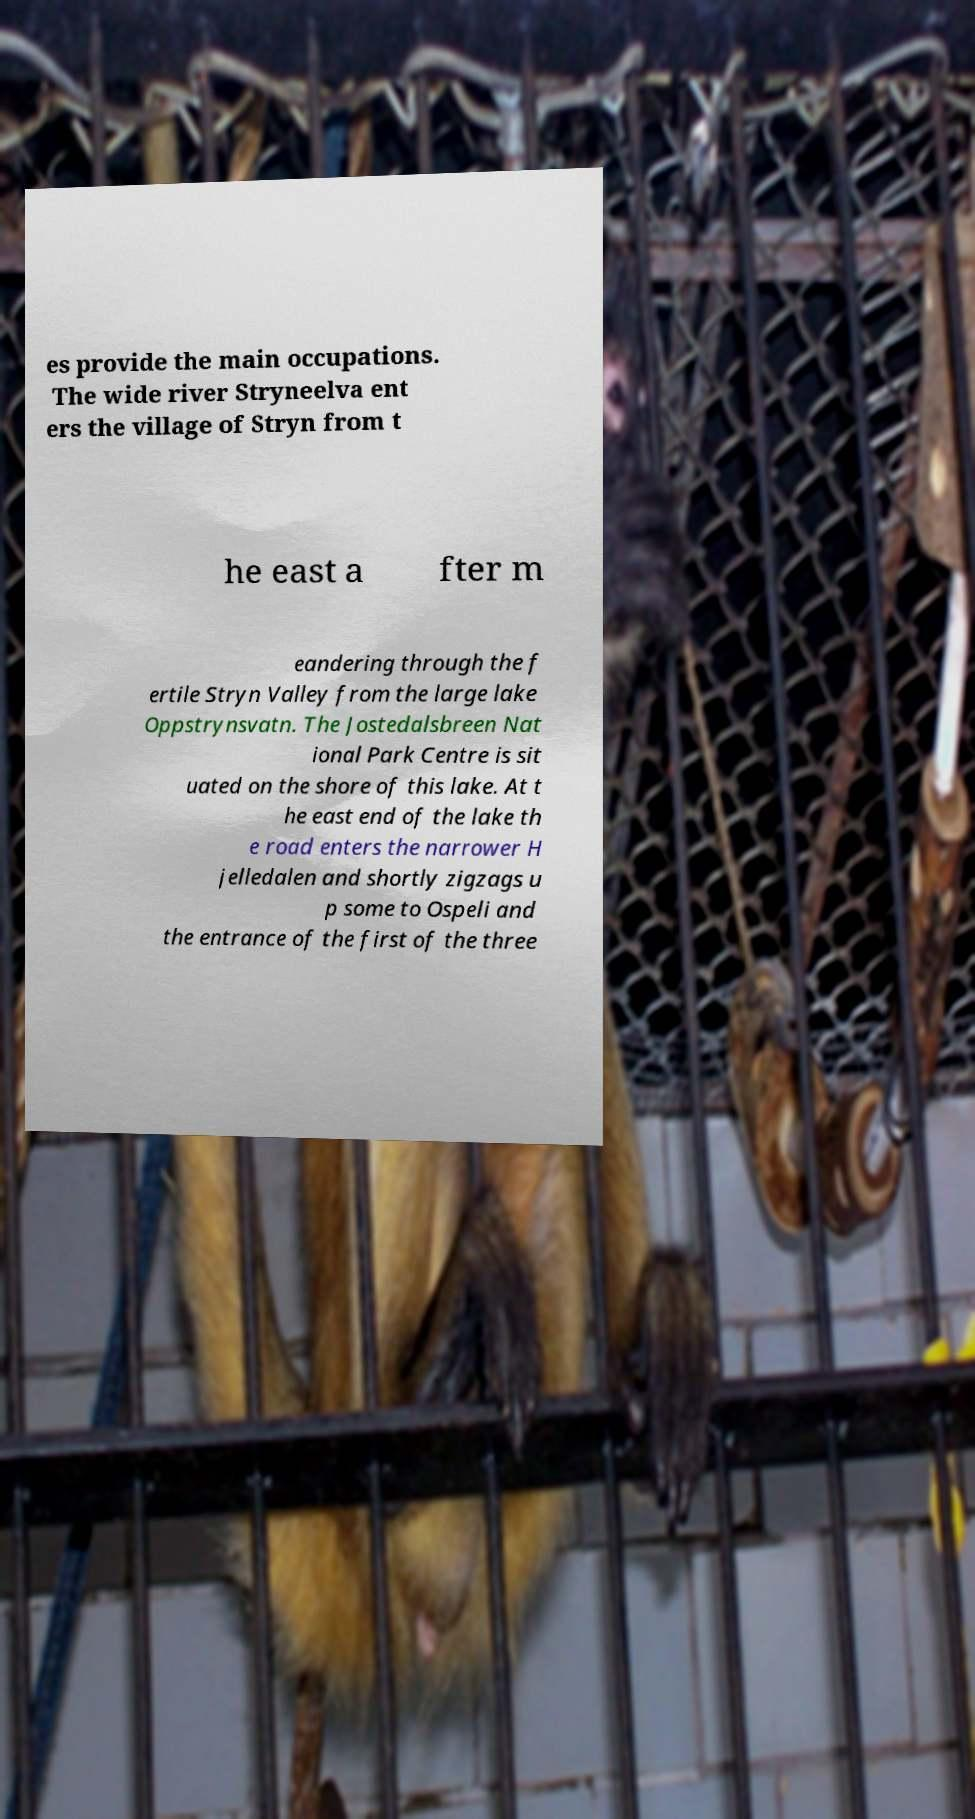Could you assist in decoding the text presented in this image and type it out clearly? es provide the main occupations. The wide river Stryneelva ent ers the village of Stryn from t he east a fter m eandering through the f ertile Stryn Valley from the large lake Oppstrynsvatn. The Jostedalsbreen Nat ional Park Centre is sit uated on the shore of this lake. At t he east end of the lake th e road enters the narrower H jelledalen and shortly zigzags u p some to Ospeli and the entrance of the first of the three 